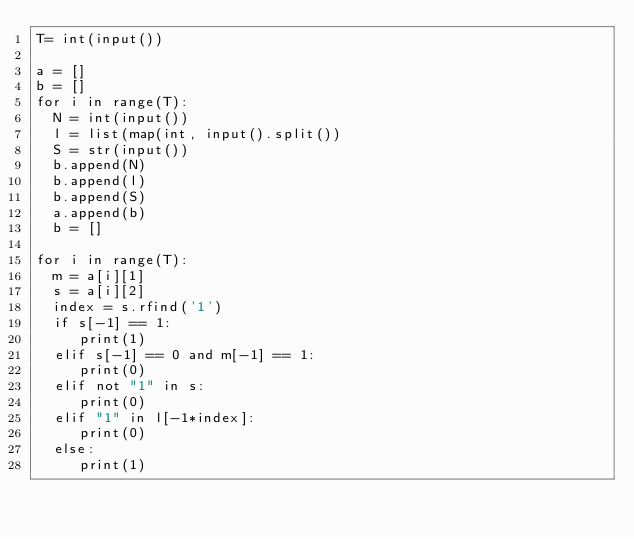Convert code to text. <code><loc_0><loc_0><loc_500><loc_500><_Python_>T= int(input())

a = []
b = []
for i in range(T):
  N = int(input())
  l = list(map(int, input().split())
  S = str(input())
  b.append(N)
  b.append(l)
  b.append(S)
  a.append(b)
  b = []

for i in range(T):
  m = a[i][1]
  s = a[i][2]
  index = s.rfind('1')
  if s[-1] == 1:
     print(1)
  elif s[-1] == 0 and m[-1] == 1:
     print(0)
  elif not "1" in s:
     print(0)
  elif "1" in l[-1*index]:
     print(0)
  else:
     print(1)</code> 